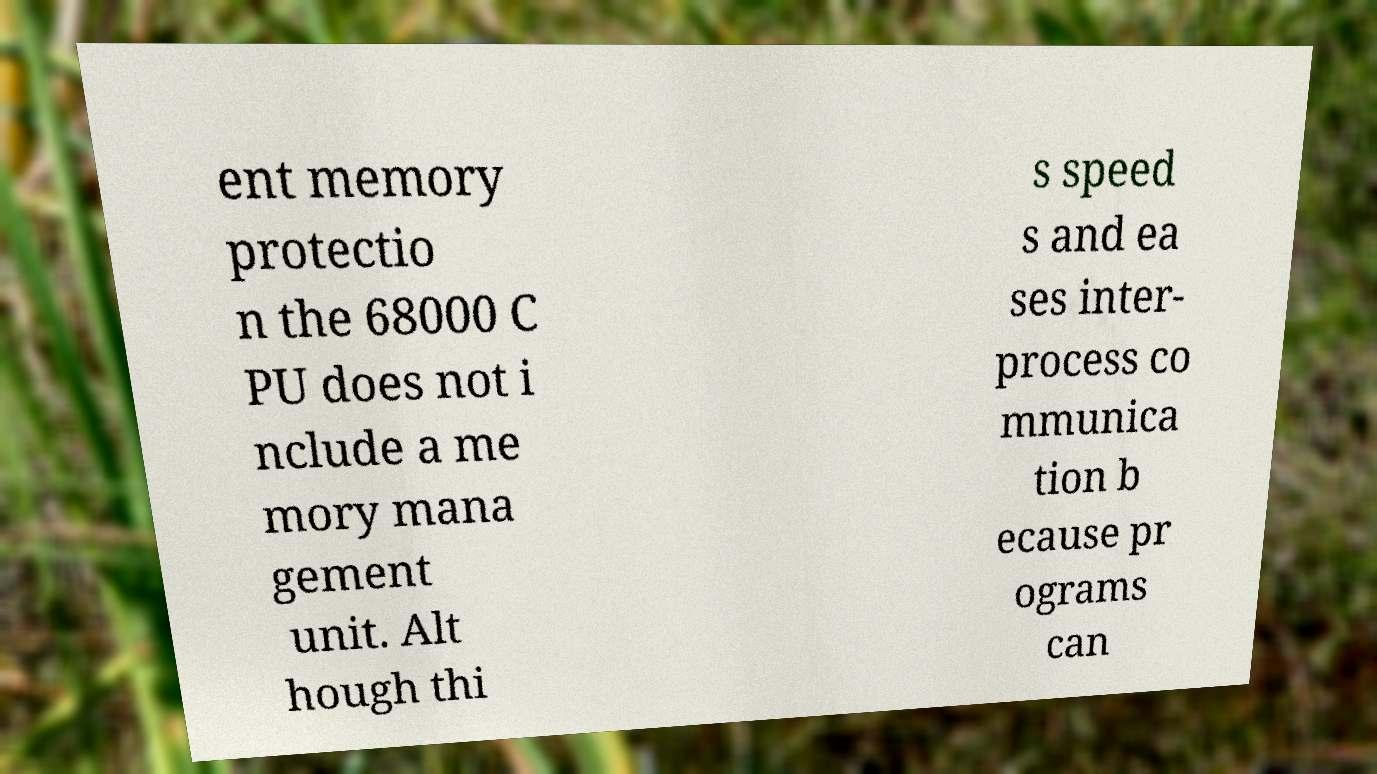Can you accurately transcribe the text from the provided image for me? ent memory protectio n the 68000 C PU does not i nclude a me mory mana gement unit. Alt hough thi s speed s and ea ses inter- process co mmunica tion b ecause pr ograms can 